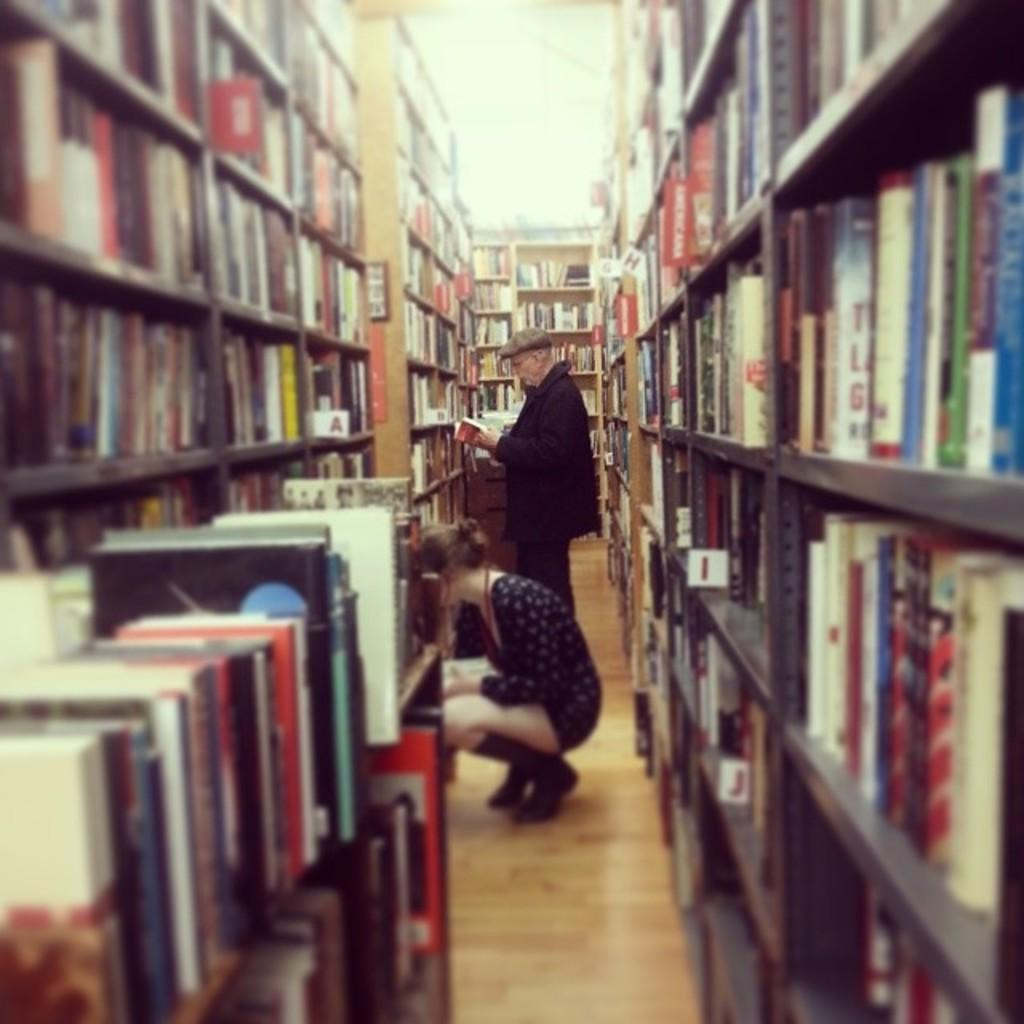<image>
Describe the image concisely. Library shelves are arranged and labeled with an alphabet system, and the letters A, B, I and J are visible. 